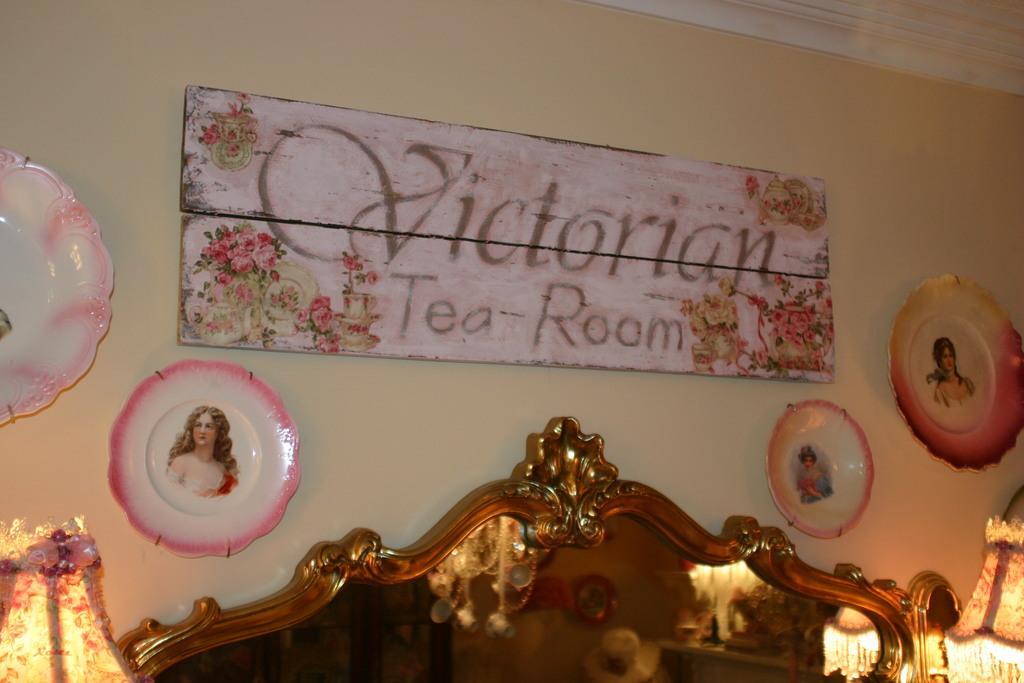Describe this image in one or two sentences. In the center of the image there is a board. On the left and right side of the image we can see plates. At the bottom there is a bed. In the background there is a wall. 